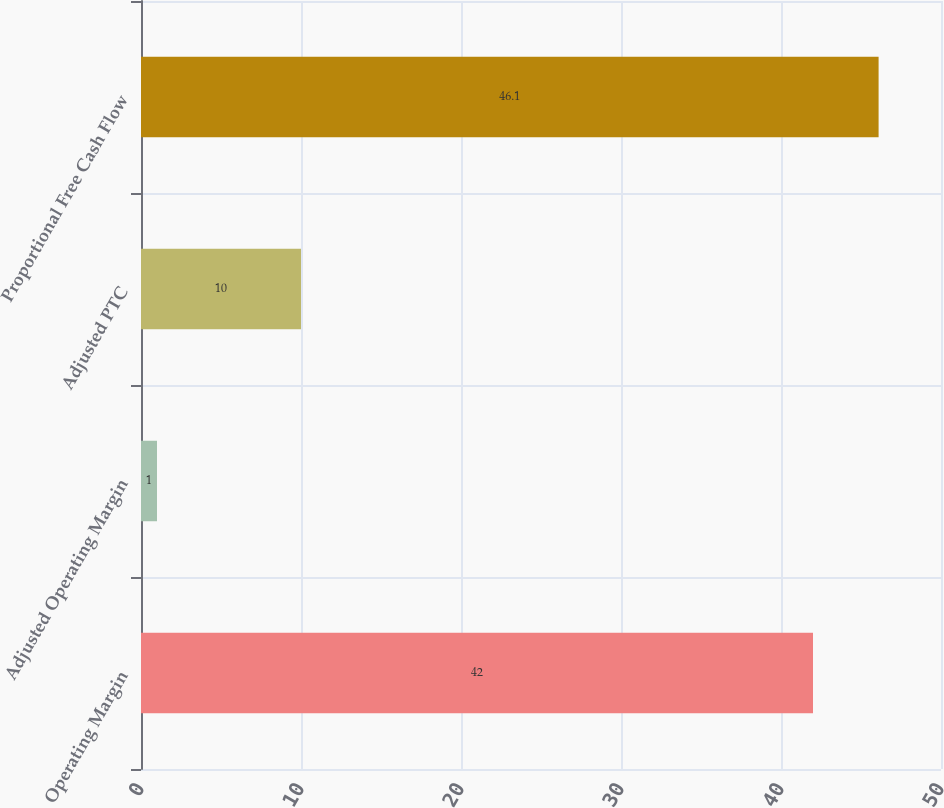Convert chart. <chart><loc_0><loc_0><loc_500><loc_500><bar_chart><fcel>Operating Margin<fcel>Adjusted Operating Margin<fcel>Adjusted PTC<fcel>Proportional Free Cash Flow<nl><fcel>42<fcel>1<fcel>10<fcel>46.1<nl></chart> 